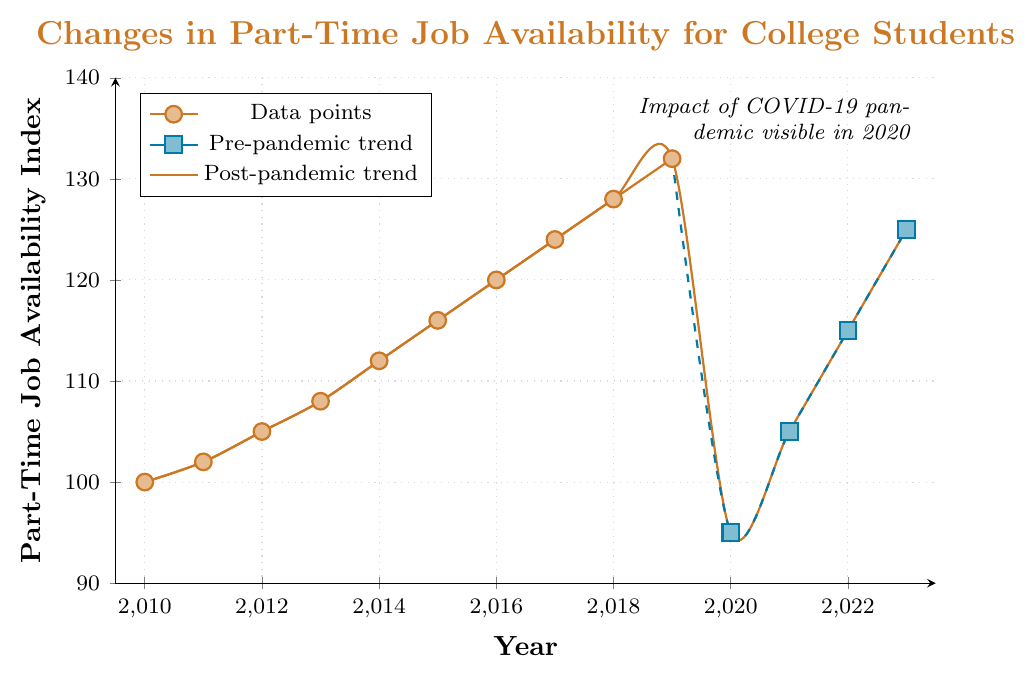What was the lowest index value observed between 2010 and 2023? To find the lowest index value, observe the y-axis values for each plotted point. The lowest index in the data is 95 in the year 2020.
Answer: 95 How did the job availability index change between 2019 and 2020? Look at the plotted points for the years 2019 and 2020. The index decreased from 132 in 2019 to 95 in 2020. The difference is 132 - 95 = 37.
Answer: Decreased by 37 Which years show a noticeable visual difference in trend style? Notice there are two different trends: one solid ochre line (pre-pandemic) and one dashed cerulean line (post-pandemic). The year transitioning these is 2019 to 2020.
Answer: 2019 and 2020 What is the average job availability index between 2010 and 2015? Sum the index values from 2010 to 2015 and divide by the number of years. (100 + 102 + 105 + 108 + 112 + 116) / 6 = 113.83
Answer: 113.83 How many years saw an increase in the job availability index compared to the previous year? Count the years where the index increased from the previous year: 2010-2011, 2011-2012, 2012-2013, 2013-2014, 2014-2015, 2015-2016, 2016-2017, 2017-2018, 2018-2019, 2020-2021, 2021-2022, 2022-2023.
Answer: 12 years What is the difference in the job availability index between 2016 and 2023? Find the index values for 2016 and 2023 and subtract: 125 (2023) - 120 (2016) = 5.
Answer: 5 In which year did the job availability index first exceed 120? Look for the first year where the index is greater than 120. In 2016, the index first exceeded 120 at exactly 120.
Answer: 2016 What do the different trend styles (solid and dashed lines) likely represent? The solid ochre line represents the pre-pandemic trend while the dashed cerulean line represents the post-pandemic trend, reflecting the impact of the COVID-19 pandemic starting in 2020.
Answer: Pre-pandemic and post-pandemic trends Which year had the fastest increase in the job availability index compared to the previous year? Calculate the year-to-year differences and find the largest increase: the biggest increase was between 2018 and 2019, from 128 to 132.
Answer: 2019 By how much did the job availability index recover from its lowest point in 2020 to 2023? The lowest point in 2020 was 95, and in 2023 it was 125. The recovery amount is 125 - 95 = 30.
Answer: 30 